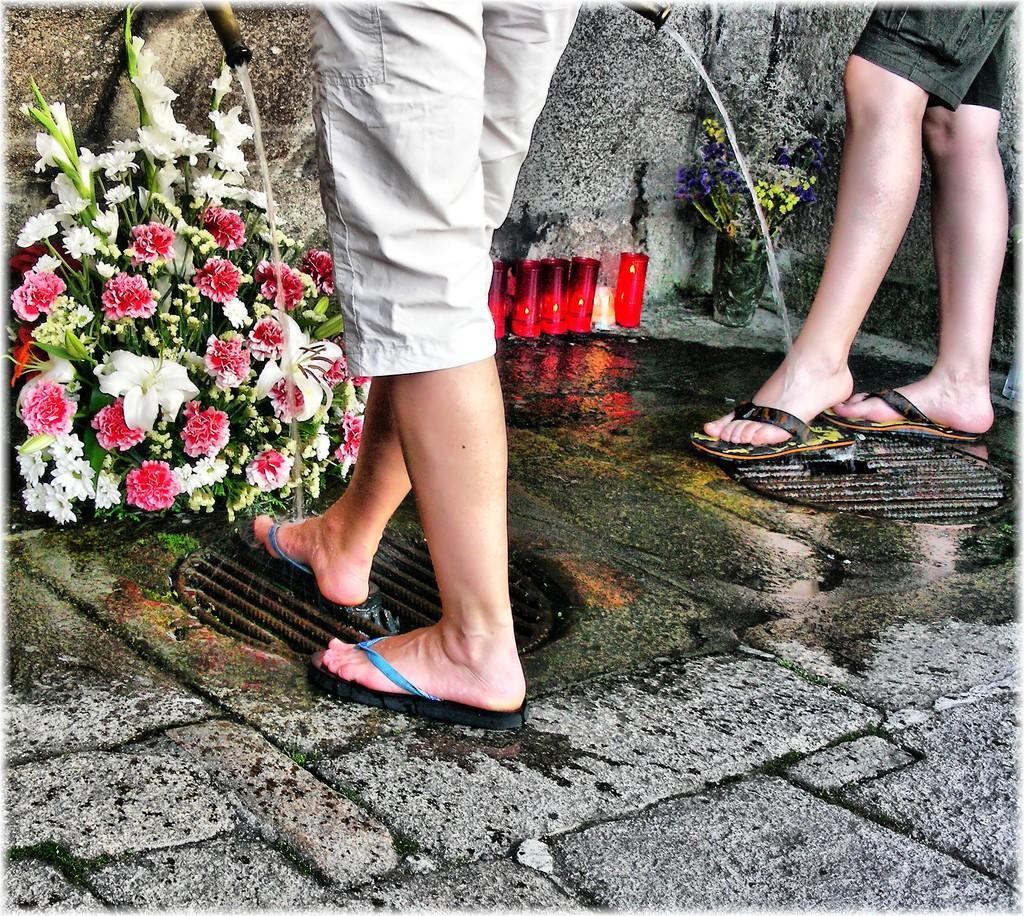How would you summarize this image in a sentence or two? In this image there are two persons legs under the taps, two flower pots, a few candles. 